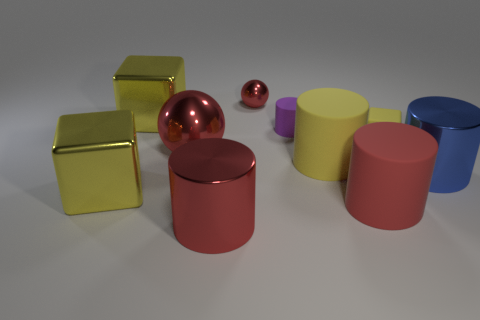Are there fewer small cylinders than big metallic things?
Provide a short and direct response. Yes. What shape is the purple object behind the big metal object left of the big metallic cube behind the blue thing?
Provide a succinct answer. Cylinder. There is a big matte object that is the same color as the tiny matte block; what is its shape?
Offer a terse response. Cylinder. Are there any tiny yellow rubber cubes?
Provide a short and direct response. Yes. There is a blue shiny cylinder; is its size the same as the red object to the right of the tiny red metal thing?
Provide a short and direct response. Yes. There is a large yellow shiny object that is behind the blue metallic object; is there a big blue metal thing that is behind it?
Keep it short and to the point. No. What material is the yellow cube that is both in front of the small purple cylinder and to the left of the large red shiny cylinder?
Your answer should be very brief. Metal. There is a large metallic cylinder that is behind the big yellow block in front of the big red sphere that is in front of the purple object; what color is it?
Your answer should be compact. Blue. There is a ball that is the same size as the blue object; what is its color?
Provide a short and direct response. Red. Do the tiny cube and the object in front of the red matte cylinder have the same color?
Keep it short and to the point. No. 